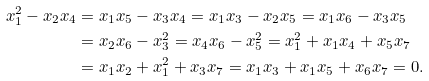Convert formula to latex. <formula><loc_0><loc_0><loc_500><loc_500>x _ { 1 } ^ { 2 } - x _ { 2 } x _ { 4 } & = x _ { 1 } x _ { 5 } - x _ { 3 } x _ { 4 } = x _ { 1 } x _ { 3 } - x _ { 2 } x _ { 5 } = x _ { 1 } x _ { 6 } - x _ { 3 } x _ { 5 } \\ & = x _ { 2 } x _ { 6 } - x _ { 3 } ^ { 2 } = x _ { 4 } x _ { 6 } - x _ { 5 } ^ { 2 } = x _ { 1 } ^ { 2 } + x _ { 1 } x _ { 4 } + x _ { 5 } x _ { 7 } \\ & = x _ { 1 } x _ { 2 } + x _ { 1 } ^ { 2 } + x _ { 3 } x _ { 7 } = x _ { 1 } x _ { 3 } + x _ { 1 } x _ { 5 } + x _ { 6 } x _ { 7 } = 0 .</formula> 